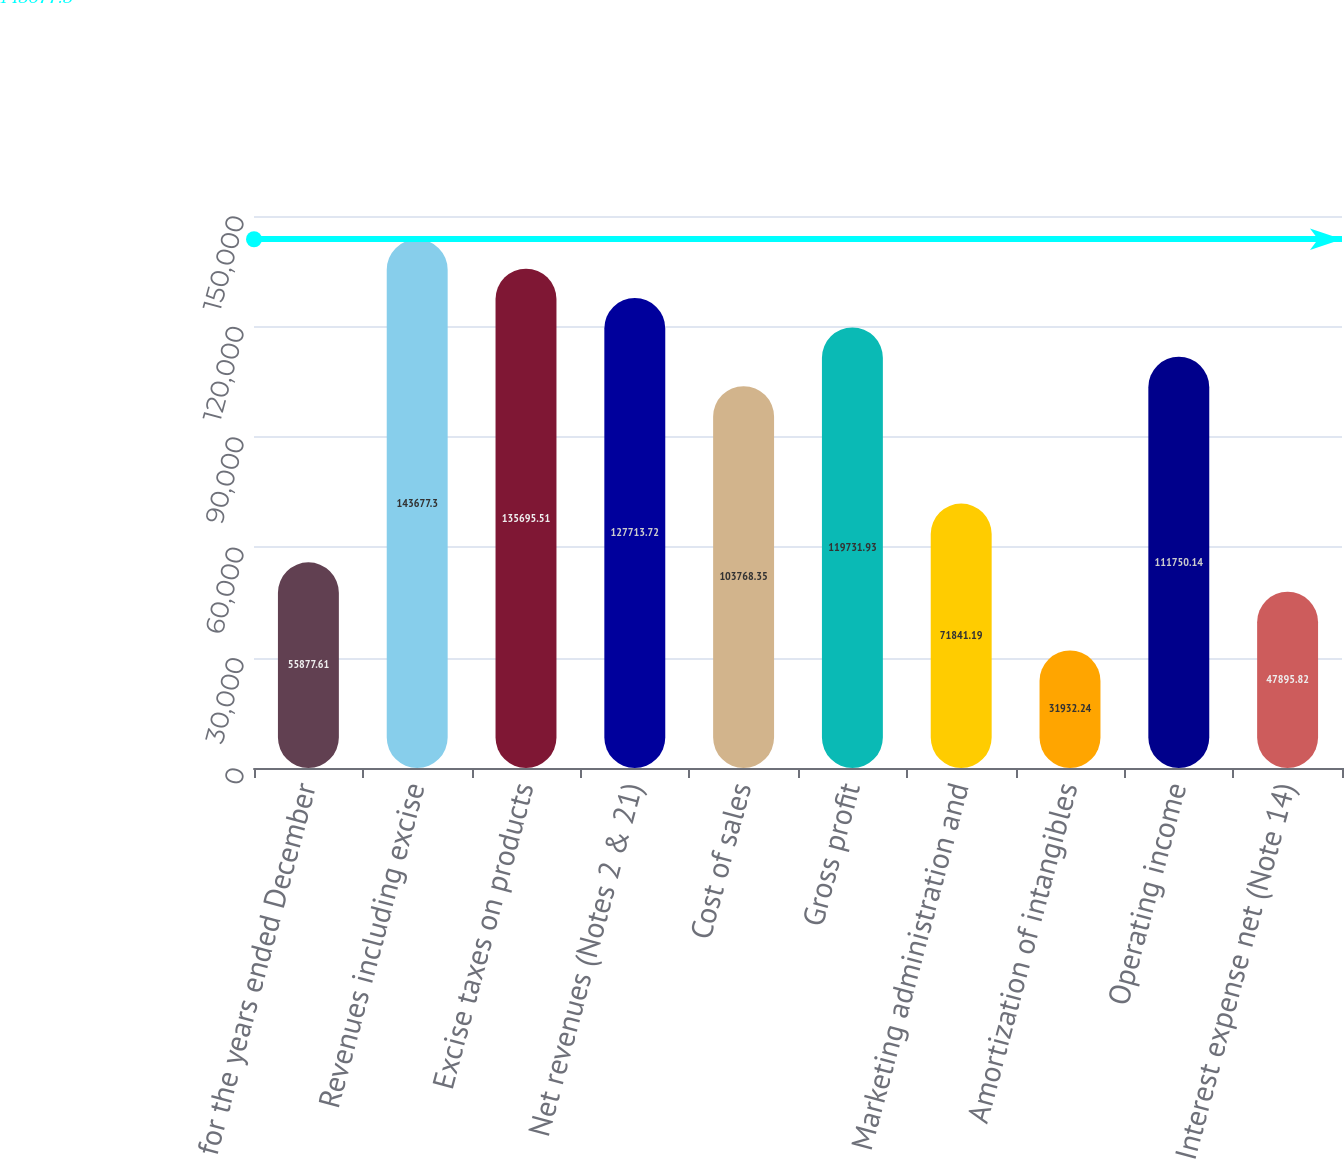Convert chart to OTSL. <chart><loc_0><loc_0><loc_500><loc_500><bar_chart><fcel>for the years ended December<fcel>Revenues including excise<fcel>Excise taxes on products<fcel>Net revenues (Notes 2 & 21)<fcel>Cost of sales<fcel>Gross profit<fcel>Marketing administration and<fcel>Amortization of intangibles<fcel>Operating income<fcel>Interest expense net (Note 14)<nl><fcel>55877.6<fcel>143677<fcel>135696<fcel>127714<fcel>103768<fcel>119732<fcel>71841.2<fcel>31932.2<fcel>111750<fcel>47895.8<nl></chart> 